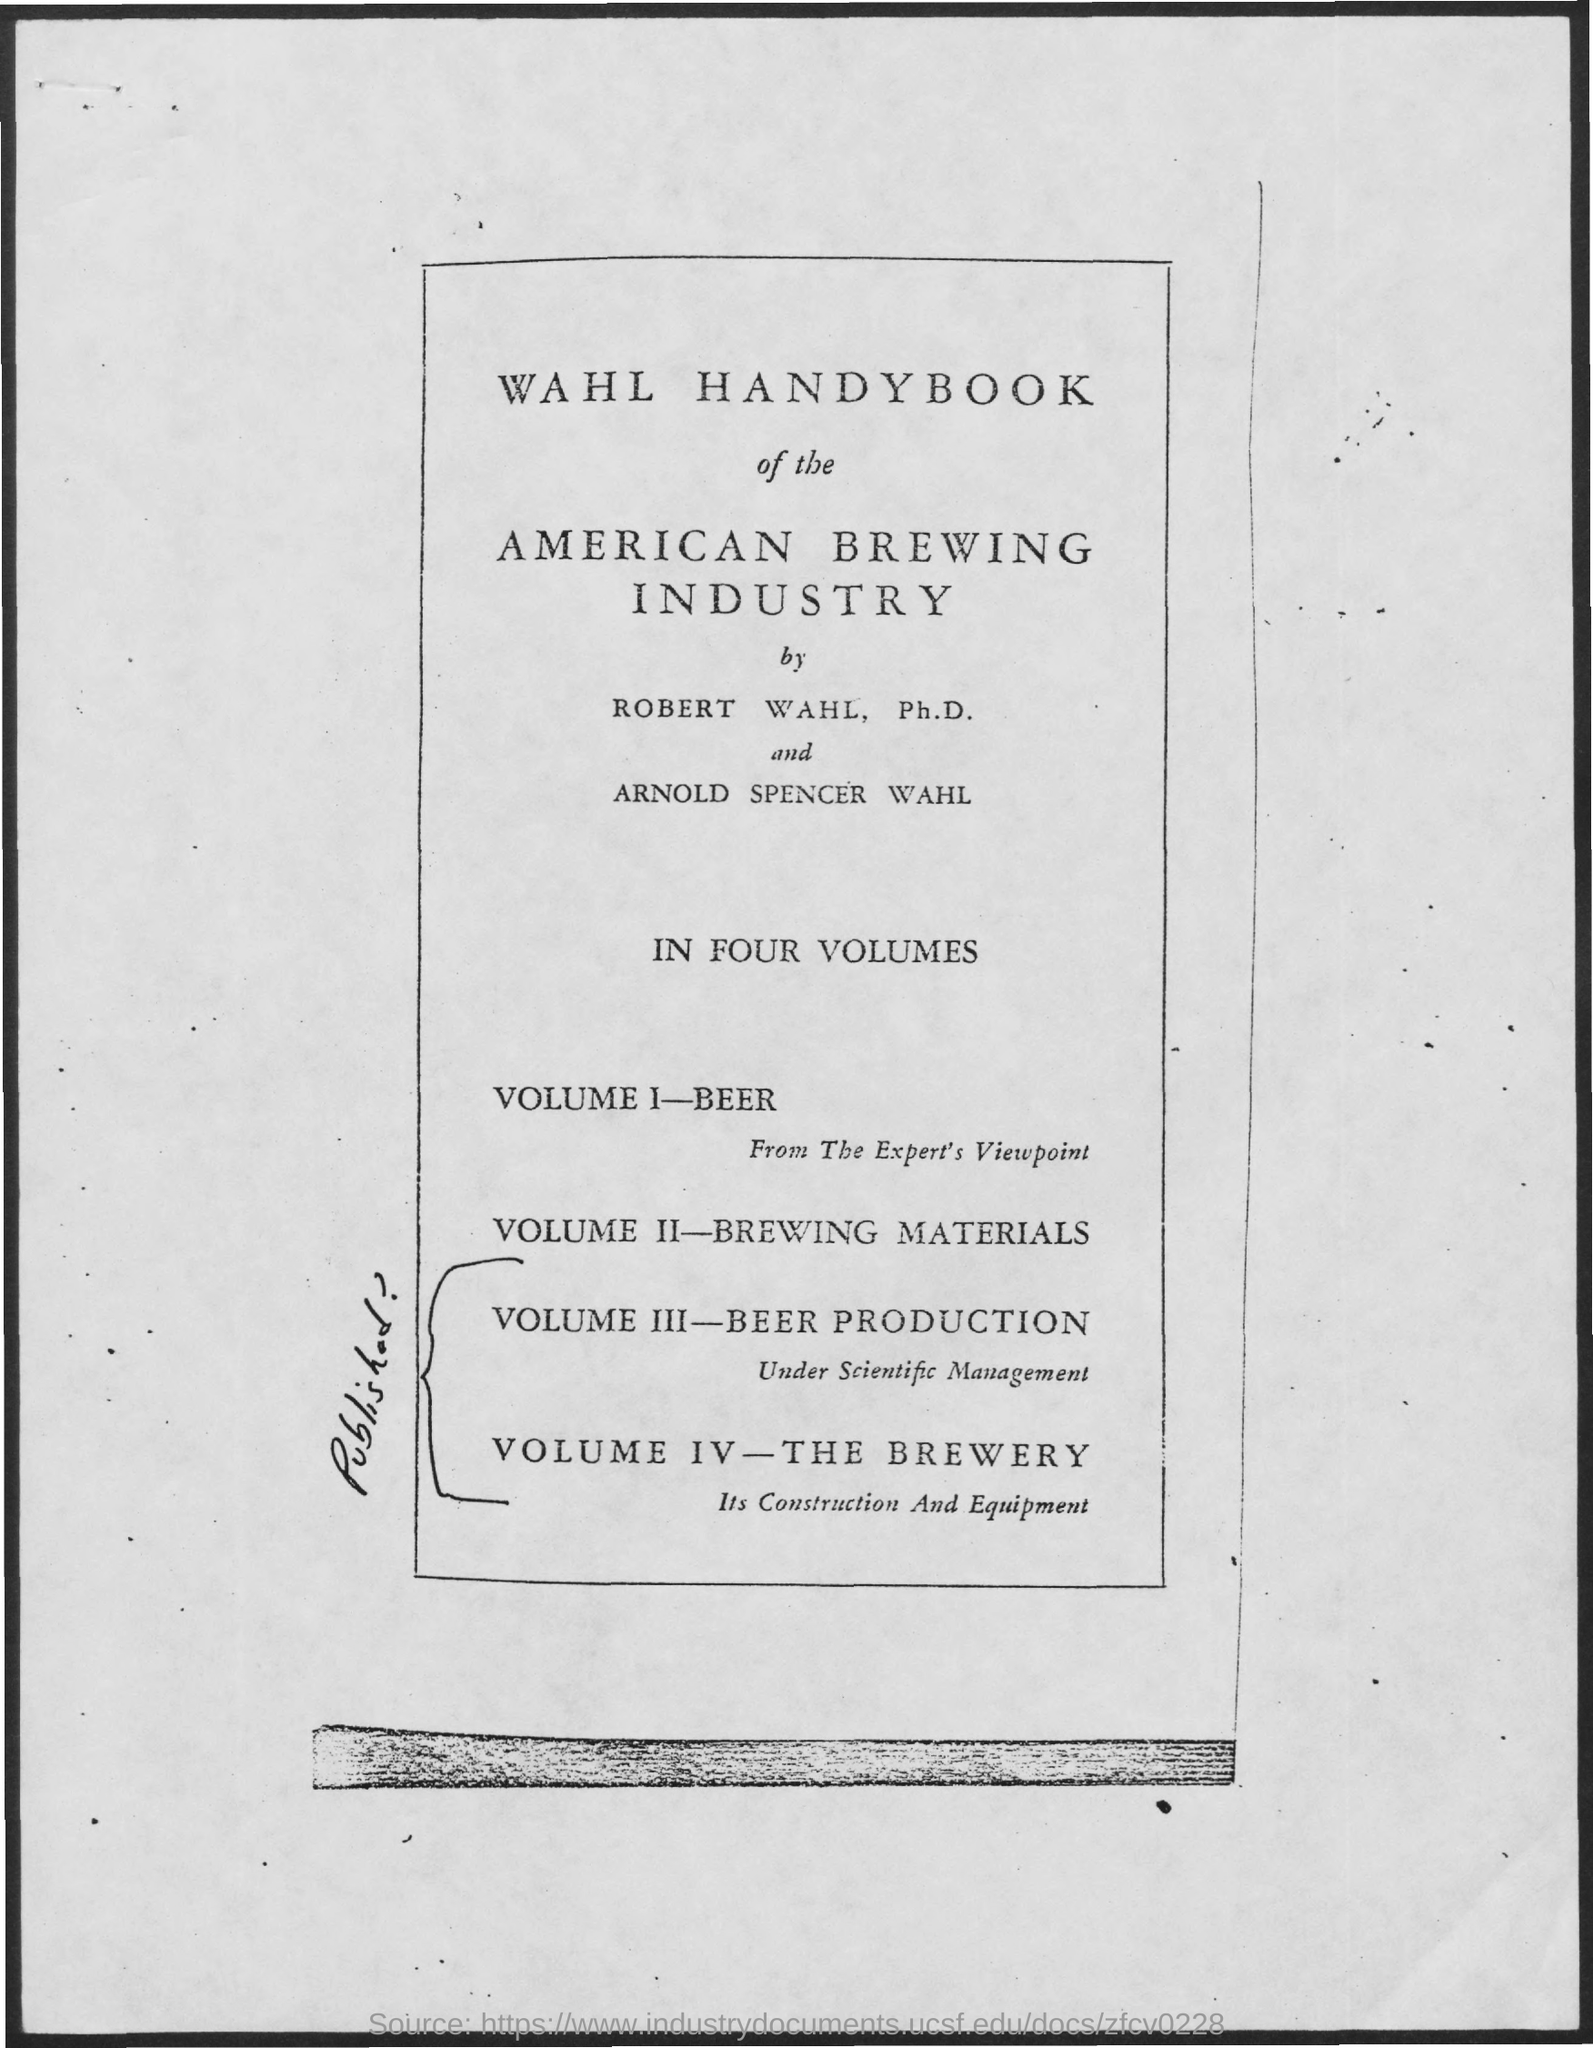Identify some key points in this picture. The American brewing industry is the name of the industry mentioned. 